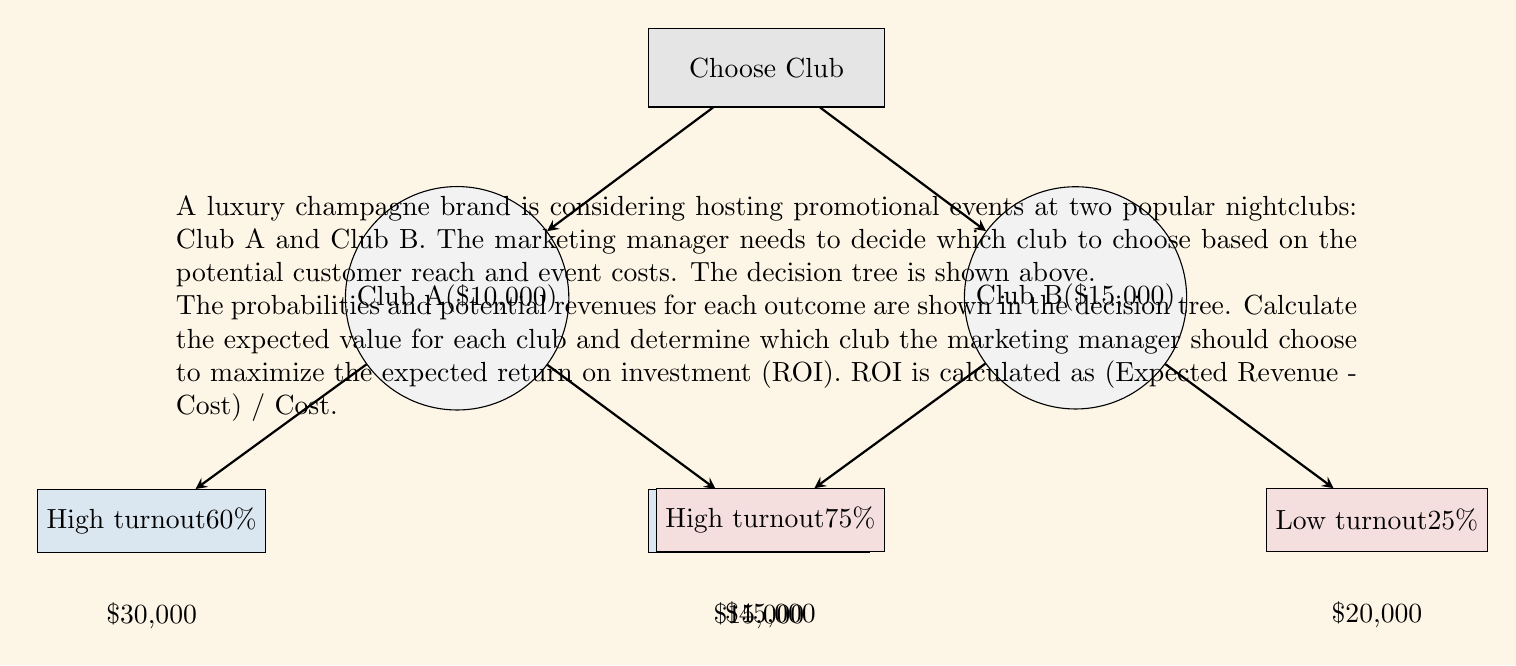What is the answer to this math problem? Let's approach this problem step-by-step:

1) First, calculate the expected revenue for each club:

   Club A:
   $E(A) = 0.60 \times \$30,000 + 0.40 \times \$15,000$
   $E(A) = \$18,000 + \$6,000 = \$24,000$

   Club B:
   $E(B) = 0.75 \times \$45,000 + 0.25 \times \$20,000$
   $E(B) = \$33,750 + \$5,000 = \$38,750$

2) Now, calculate the expected ROI for each club:

   Club A:
   $ROI_A = \frac{E(A) - Cost_A}{Cost_A} = \frac{\$24,000 - \$10,000}{\$10,000} = 1.40 = 140\%$

   Club B:
   $ROI_B = \frac{E(B) - Cost_B}{Cost_B} = \frac{\$38,750 - \$15,000}{\$15,000} = 1.58 = 158\%$

3) Compare the ROIs:

   Club B has a higher expected ROI (158%) compared to Club A (140%).

Therefore, to maximize the expected return on investment, the marketing manager should choose Club B.
Answer: Choose Club B; ROI = 158% 